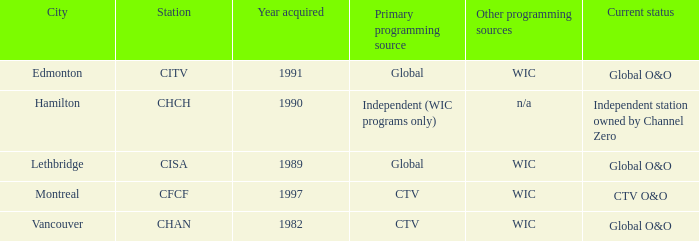Would you be able to parse every entry in this table? {'header': ['City', 'Station', 'Year acquired', 'Primary programming source', 'Other programming sources', 'Current status'], 'rows': [['Edmonton', 'CITV', '1991', 'Global', 'WIC', 'Global O&O'], ['Hamilton', 'CHCH', '1990', 'Independent (WIC programs only)', 'n/a', 'Independent station owned by Channel Zero'], ['Lethbridge', 'CISA', '1989', 'Global', 'WIC', 'Global O&O'], ['Montreal', 'CFCF', '1997', 'CTV', 'WIC', 'CTV O&O'], ['Vancouver', 'CHAN', '1982', 'CTV', 'WIC', 'Global O&O']]} How any were gained as the chan 1.0. 